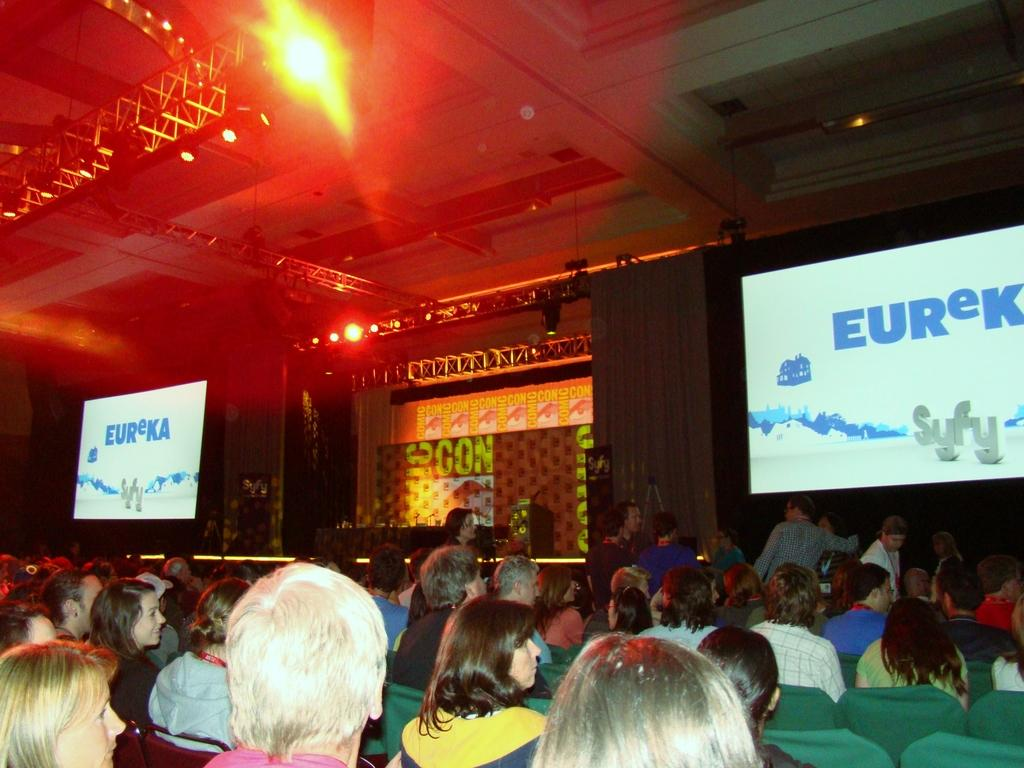What are the people in the image doing? The people in the image are sitting on chairs. What objects can be seen in the image that are used for displaying visuals? There are two projectors visible in the image. Where are some people located in relation to the chairs? There are people on stage in the image. What type of collar is being worn by the picture in the image? There is no picture or collar present in the image. 